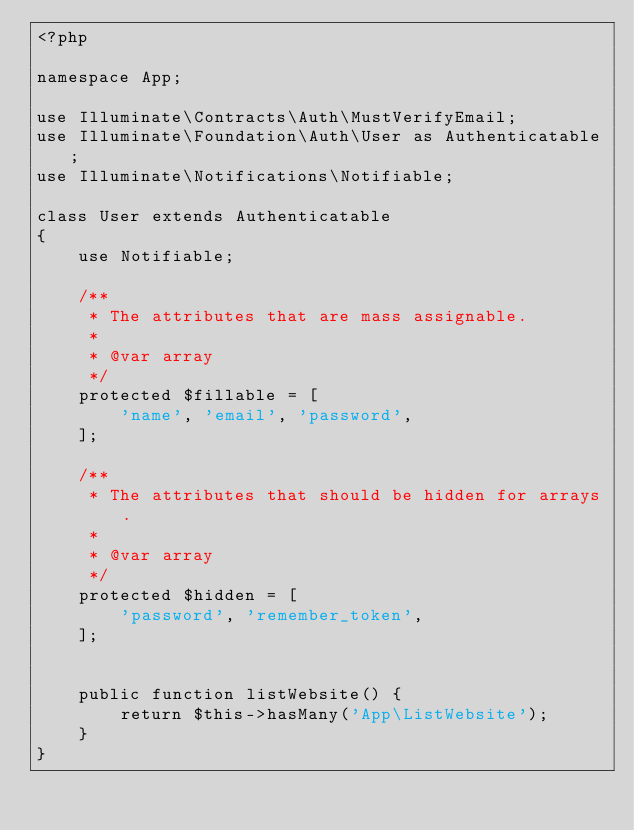Convert code to text. <code><loc_0><loc_0><loc_500><loc_500><_PHP_><?php

namespace App;

use Illuminate\Contracts\Auth\MustVerifyEmail;
use Illuminate\Foundation\Auth\User as Authenticatable;
use Illuminate\Notifications\Notifiable;

class User extends Authenticatable
{
    use Notifiable;

    /**
     * The attributes that are mass assignable.
     *
     * @var array
     */
    protected $fillable = [
        'name', 'email', 'password',
    ];

    /**
     * The attributes that should be hidden for arrays.
     *
     * @var array
     */
    protected $hidden = [
        'password', 'remember_token',
    ];


    public function listWebsite() {
        return $this->hasMany('App\ListWebsite');
    }
}
</code> 